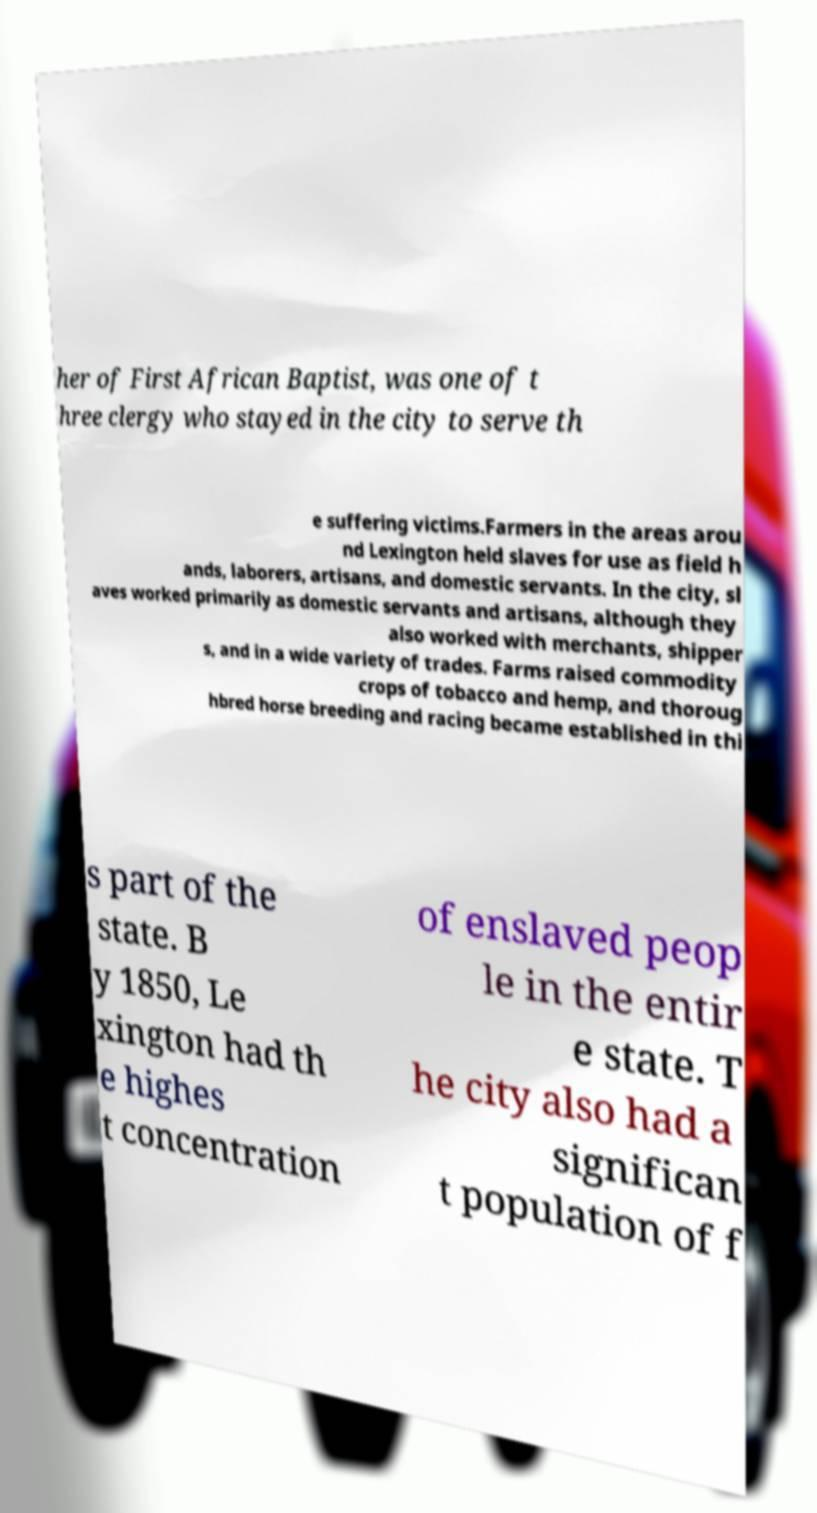Can you accurately transcribe the text from the provided image for me? her of First African Baptist, was one of t hree clergy who stayed in the city to serve th e suffering victims.Farmers in the areas arou nd Lexington held slaves for use as field h ands, laborers, artisans, and domestic servants. In the city, sl aves worked primarily as domestic servants and artisans, although they also worked with merchants, shipper s, and in a wide variety of trades. Farms raised commodity crops of tobacco and hemp, and thoroug hbred horse breeding and racing became established in thi s part of the state. B y 1850, Le xington had th e highes t concentration of enslaved peop le in the entir e state. T he city also had a significan t population of f 